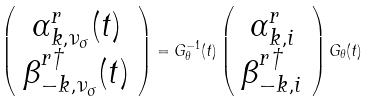Convert formula to latex. <formula><loc_0><loc_0><loc_500><loc_500>\left ( \begin{array} { c } \alpha ^ { r } _ { { k } , \nu _ { \sigma } } ( t ) \\ \beta ^ { r \dag } _ { { - k } , \nu _ { \sigma } } ( t ) \end{array} \right ) = G ^ { - 1 } _ { \theta } ( t ) \left ( \begin{array} { c } \alpha ^ { r } _ { { k } , i } \\ \beta ^ { r \dag } _ { { - k } , i } \end{array} \right ) G _ { \theta } ( t )</formula> 